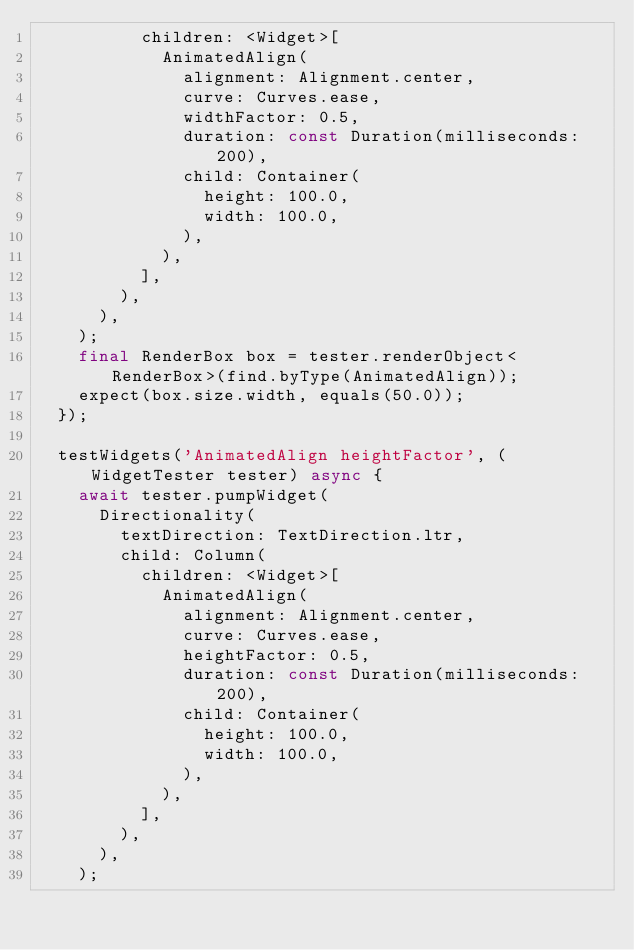<code> <loc_0><loc_0><loc_500><loc_500><_Dart_>          children: <Widget>[
            AnimatedAlign(
              alignment: Alignment.center,
              curve: Curves.ease,
              widthFactor: 0.5,
              duration: const Duration(milliseconds: 200),
              child: Container(
                height: 100.0,
                width: 100.0,
              ),
            ),
          ],
        ),
      ),
    );
    final RenderBox box = tester.renderObject<RenderBox>(find.byType(AnimatedAlign));
    expect(box.size.width, equals(50.0));
  });

  testWidgets('AnimatedAlign heightFactor', (WidgetTester tester) async {
    await tester.pumpWidget(
      Directionality(
        textDirection: TextDirection.ltr,
        child: Column(
          children: <Widget>[
            AnimatedAlign(
              alignment: Alignment.center,
              curve: Curves.ease,
              heightFactor: 0.5,
              duration: const Duration(milliseconds: 200),
              child: Container(
                height: 100.0,
                width: 100.0,
              ),
            ),
          ],
        ),
      ),
    );</code> 